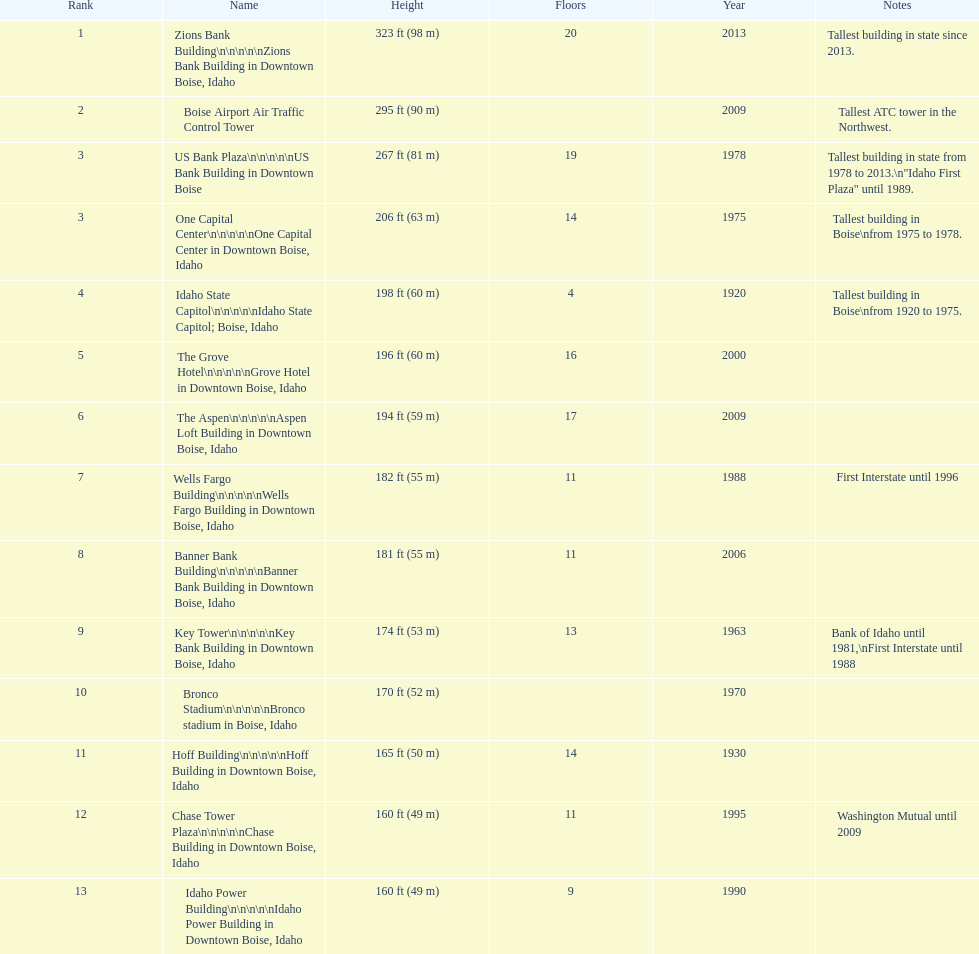What are the number of floors the us bank plaza has? 19. 